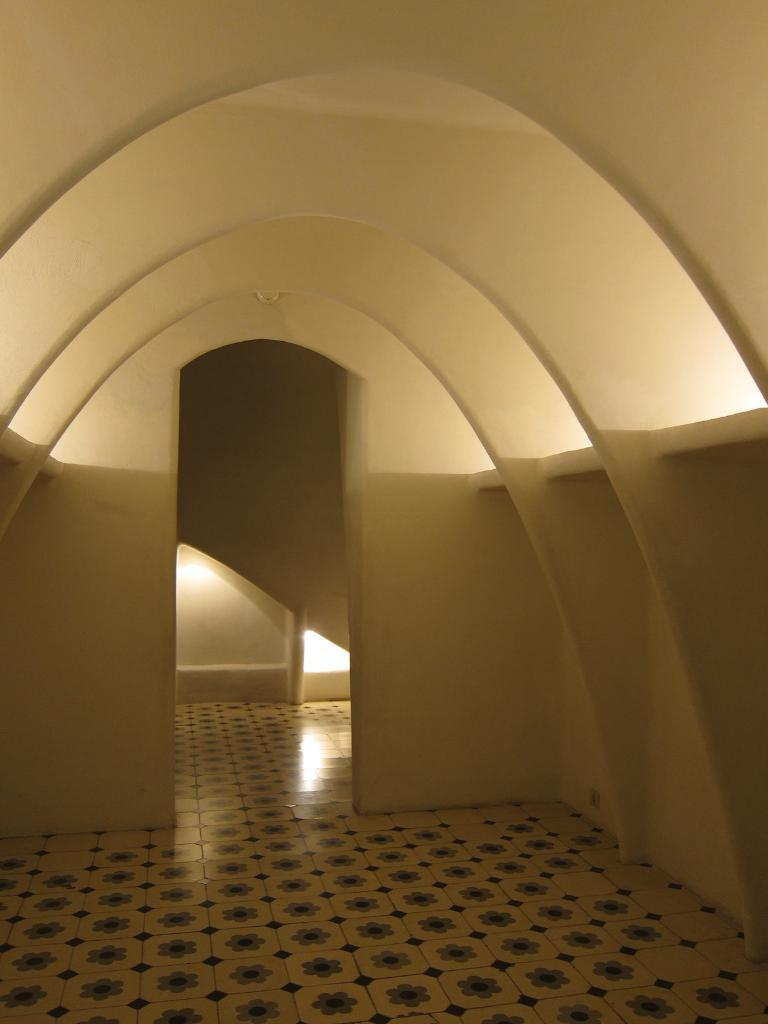What type of setting is depicted in the image? The image shows an interior view of a building. Can you describe any specific features within the building? There is a light focus visible on the wall in the middle of the image. What type of form or order is being displayed by the fear in the image? There is no fear present in the image, and therefore no form or order related to fear can be observed. 